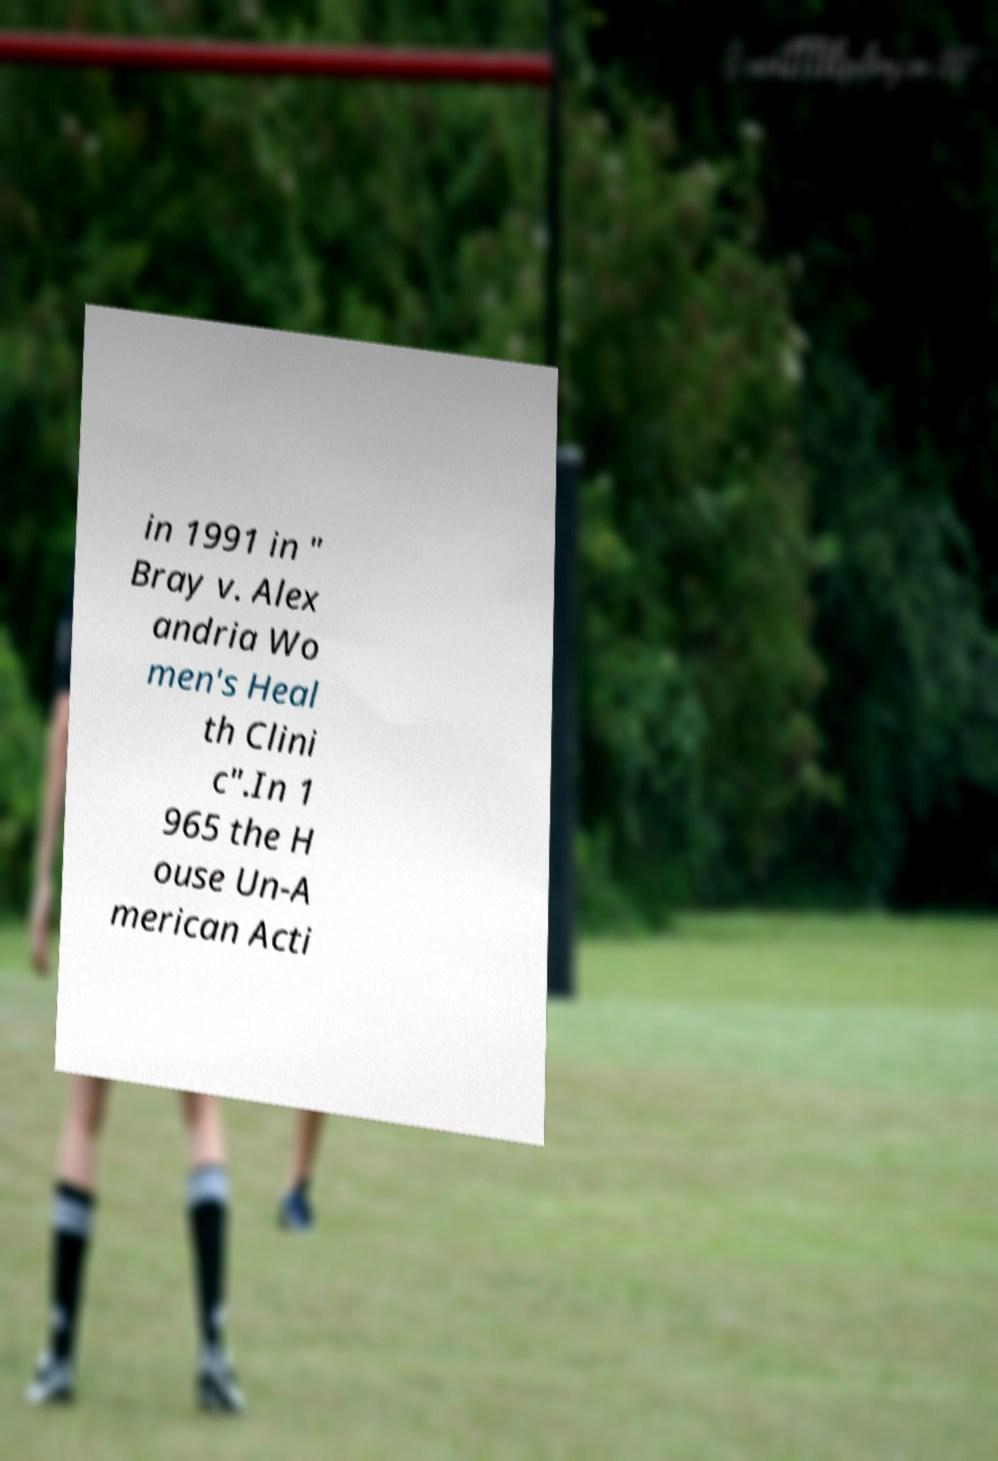For documentation purposes, I need the text within this image transcribed. Could you provide that? in 1991 in " Bray v. Alex andria Wo men's Heal th Clini c".In 1 965 the H ouse Un-A merican Acti 